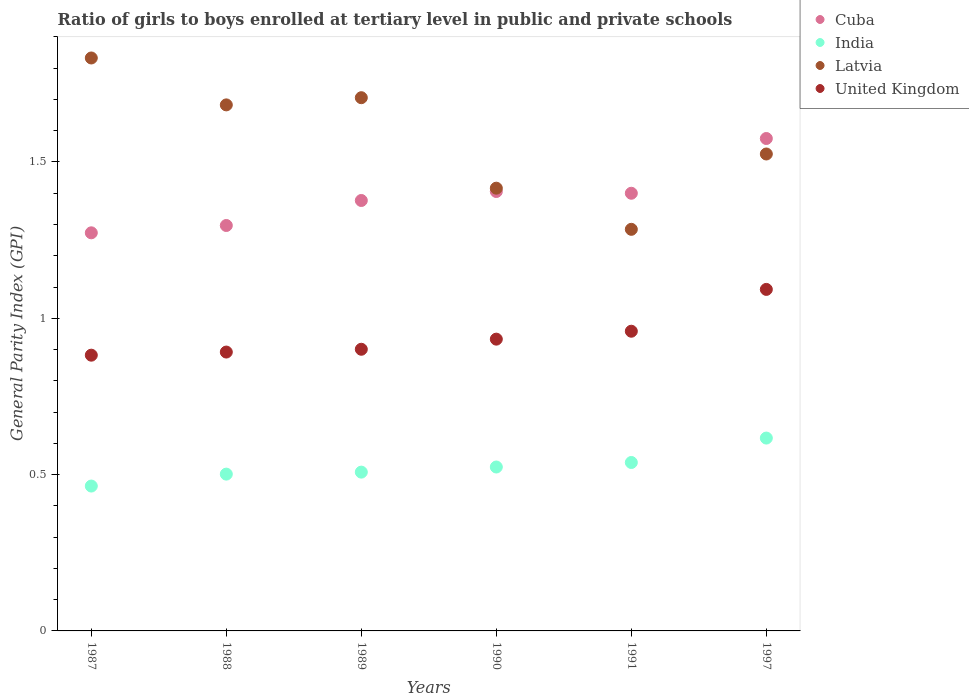How many different coloured dotlines are there?
Provide a short and direct response. 4. Is the number of dotlines equal to the number of legend labels?
Provide a short and direct response. Yes. What is the general parity index in India in 1988?
Give a very brief answer. 0.5. Across all years, what is the maximum general parity index in Cuba?
Offer a very short reply. 1.57. Across all years, what is the minimum general parity index in United Kingdom?
Offer a terse response. 0.88. In which year was the general parity index in Latvia maximum?
Offer a very short reply. 1987. What is the total general parity index in Latvia in the graph?
Ensure brevity in your answer.  9.45. What is the difference between the general parity index in United Kingdom in 1987 and that in 1989?
Make the answer very short. -0.02. What is the difference between the general parity index in United Kingdom in 1989 and the general parity index in India in 1990?
Your response must be concise. 0.38. What is the average general parity index in Latvia per year?
Provide a short and direct response. 1.57. In the year 1987, what is the difference between the general parity index in United Kingdom and general parity index in Latvia?
Give a very brief answer. -0.95. What is the ratio of the general parity index in Cuba in 1989 to that in 1991?
Make the answer very short. 0.98. Is the general parity index in Cuba in 1988 less than that in 1989?
Offer a terse response. Yes. Is the difference between the general parity index in United Kingdom in 1987 and 1997 greater than the difference between the general parity index in Latvia in 1987 and 1997?
Your answer should be compact. No. What is the difference between the highest and the second highest general parity index in United Kingdom?
Make the answer very short. 0.13. What is the difference between the highest and the lowest general parity index in Latvia?
Make the answer very short. 0.55. Is the sum of the general parity index in Cuba in 1988 and 1997 greater than the maximum general parity index in United Kingdom across all years?
Offer a terse response. Yes. Is it the case that in every year, the sum of the general parity index in Latvia and general parity index in India  is greater than the general parity index in United Kingdom?
Ensure brevity in your answer.  Yes. Does the general parity index in India monotonically increase over the years?
Ensure brevity in your answer.  Yes. How many years are there in the graph?
Ensure brevity in your answer.  6. What is the difference between two consecutive major ticks on the Y-axis?
Make the answer very short. 0.5. Are the values on the major ticks of Y-axis written in scientific E-notation?
Your answer should be compact. No. Does the graph contain any zero values?
Offer a very short reply. No. Where does the legend appear in the graph?
Provide a succinct answer. Top right. How many legend labels are there?
Your answer should be very brief. 4. How are the legend labels stacked?
Ensure brevity in your answer.  Vertical. What is the title of the graph?
Your response must be concise. Ratio of girls to boys enrolled at tertiary level in public and private schools. Does "Iran" appear as one of the legend labels in the graph?
Give a very brief answer. No. What is the label or title of the X-axis?
Offer a very short reply. Years. What is the label or title of the Y-axis?
Provide a short and direct response. General Parity Index (GPI). What is the General Parity Index (GPI) of Cuba in 1987?
Provide a short and direct response. 1.27. What is the General Parity Index (GPI) in India in 1987?
Offer a terse response. 0.46. What is the General Parity Index (GPI) in Latvia in 1987?
Your answer should be very brief. 1.83. What is the General Parity Index (GPI) of United Kingdom in 1987?
Ensure brevity in your answer.  0.88. What is the General Parity Index (GPI) in Cuba in 1988?
Ensure brevity in your answer.  1.3. What is the General Parity Index (GPI) of India in 1988?
Offer a very short reply. 0.5. What is the General Parity Index (GPI) of Latvia in 1988?
Your answer should be very brief. 1.68. What is the General Parity Index (GPI) in United Kingdom in 1988?
Your answer should be very brief. 0.89. What is the General Parity Index (GPI) in Cuba in 1989?
Give a very brief answer. 1.38. What is the General Parity Index (GPI) of India in 1989?
Keep it short and to the point. 0.51. What is the General Parity Index (GPI) in Latvia in 1989?
Offer a terse response. 1.71. What is the General Parity Index (GPI) of United Kingdom in 1989?
Keep it short and to the point. 0.9. What is the General Parity Index (GPI) of Cuba in 1990?
Keep it short and to the point. 1.41. What is the General Parity Index (GPI) in India in 1990?
Your response must be concise. 0.52. What is the General Parity Index (GPI) of Latvia in 1990?
Offer a very short reply. 1.42. What is the General Parity Index (GPI) of United Kingdom in 1990?
Provide a short and direct response. 0.93. What is the General Parity Index (GPI) of Cuba in 1991?
Ensure brevity in your answer.  1.4. What is the General Parity Index (GPI) of India in 1991?
Give a very brief answer. 0.54. What is the General Parity Index (GPI) in Latvia in 1991?
Your answer should be compact. 1.28. What is the General Parity Index (GPI) of United Kingdom in 1991?
Provide a succinct answer. 0.96. What is the General Parity Index (GPI) in Cuba in 1997?
Keep it short and to the point. 1.57. What is the General Parity Index (GPI) of India in 1997?
Provide a short and direct response. 0.62. What is the General Parity Index (GPI) of Latvia in 1997?
Give a very brief answer. 1.53. What is the General Parity Index (GPI) in United Kingdom in 1997?
Offer a very short reply. 1.09. Across all years, what is the maximum General Parity Index (GPI) in Cuba?
Your response must be concise. 1.57. Across all years, what is the maximum General Parity Index (GPI) of India?
Give a very brief answer. 0.62. Across all years, what is the maximum General Parity Index (GPI) in Latvia?
Offer a terse response. 1.83. Across all years, what is the maximum General Parity Index (GPI) of United Kingdom?
Make the answer very short. 1.09. Across all years, what is the minimum General Parity Index (GPI) in Cuba?
Ensure brevity in your answer.  1.27. Across all years, what is the minimum General Parity Index (GPI) of India?
Give a very brief answer. 0.46. Across all years, what is the minimum General Parity Index (GPI) of Latvia?
Provide a succinct answer. 1.28. Across all years, what is the minimum General Parity Index (GPI) of United Kingdom?
Provide a succinct answer. 0.88. What is the total General Parity Index (GPI) in Cuba in the graph?
Provide a short and direct response. 8.33. What is the total General Parity Index (GPI) in India in the graph?
Your response must be concise. 3.15. What is the total General Parity Index (GPI) of Latvia in the graph?
Offer a very short reply. 9.45. What is the total General Parity Index (GPI) of United Kingdom in the graph?
Ensure brevity in your answer.  5.66. What is the difference between the General Parity Index (GPI) of Cuba in 1987 and that in 1988?
Your answer should be compact. -0.02. What is the difference between the General Parity Index (GPI) in India in 1987 and that in 1988?
Keep it short and to the point. -0.04. What is the difference between the General Parity Index (GPI) in Latvia in 1987 and that in 1988?
Your response must be concise. 0.15. What is the difference between the General Parity Index (GPI) of United Kingdom in 1987 and that in 1988?
Provide a short and direct response. -0.01. What is the difference between the General Parity Index (GPI) in Cuba in 1987 and that in 1989?
Give a very brief answer. -0.1. What is the difference between the General Parity Index (GPI) of India in 1987 and that in 1989?
Your answer should be very brief. -0.04. What is the difference between the General Parity Index (GPI) of Latvia in 1987 and that in 1989?
Provide a short and direct response. 0.13. What is the difference between the General Parity Index (GPI) in United Kingdom in 1987 and that in 1989?
Provide a succinct answer. -0.02. What is the difference between the General Parity Index (GPI) in Cuba in 1987 and that in 1990?
Provide a short and direct response. -0.13. What is the difference between the General Parity Index (GPI) of India in 1987 and that in 1990?
Give a very brief answer. -0.06. What is the difference between the General Parity Index (GPI) of Latvia in 1987 and that in 1990?
Provide a short and direct response. 0.42. What is the difference between the General Parity Index (GPI) in United Kingdom in 1987 and that in 1990?
Make the answer very short. -0.05. What is the difference between the General Parity Index (GPI) of Cuba in 1987 and that in 1991?
Provide a short and direct response. -0.13. What is the difference between the General Parity Index (GPI) in India in 1987 and that in 1991?
Your answer should be very brief. -0.08. What is the difference between the General Parity Index (GPI) of Latvia in 1987 and that in 1991?
Provide a succinct answer. 0.55. What is the difference between the General Parity Index (GPI) in United Kingdom in 1987 and that in 1991?
Your answer should be compact. -0.08. What is the difference between the General Parity Index (GPI) of Cuba in 1987 and that in 1997?
Provide a succinct answer. -0.3. What is the difference between the General Parity Index (GPI) in India in 1987 and that in 1997?
Offer a terse response. -0.15. What is the difference between the General Parity Index (GPI) of Latvia in 1987 and that in 1997?
Offer a very short reply. 0.31. What is the difference between the General Parity Index (GPI) in United Kingdom in 1987 and that in 1997?
Keep it short and to the point. -0.21. What is the difference between the General Parity Index (GPI) of Cuba in 1988 and that in 1989?
Offer a terse response. -0.08. What is the difference between the General Parity Index (GPI) of India in 1988 and that in 1989?
Offer a very short reply. -0.01. What is the difference between the General Parity Index (GPI) in Latvia in 1988 and that in 1989?
Provide a short and direct response. -0.02. What is the difference between the General Parity Index (GPI) of United Kingdom in 1988 and that in 1989?
Give a very brief answer. -0.01. What is the difference between the General Parity Index (GPI) of Cuba in 1988 and that in 1990?
Provide a short and direct response. -0.11. What is the difference between the General Parity Index (GPI) of India in 1988 and that in 1990?
Your answer should be very brief. -0.02. What is the difference between the General Parity Index (GPI) of Latvia in 1988 and that in 1990?
Give a very brief answer. 0.27. What is the difference between the General Parity Index (GPI) in United Kingdom in 1988 and that in 1990?
Provide a short and direct response. -0.04. What is the difference between the General Parity Index (GPI) of Cuba in 1988 and that in 1991?
Your answer should be very brief. -0.1. What is the difference between the General Parity Index (GPI) of India in 1988 and that in 1991?
Offer a terse response. -0.04. What is the difference between the General Parity Index (GPI) of Latvia in 1988 and that in 1991?
Keep it short and to the point. 0.4. What is the difference between the General Parity Index (GPI) in United Kingdom in 1988 and that in 1991?
Offer a terse response. -0.07. What is the difference between the General Parity Index (GPI) in Cuba in 1988 and that in 1997?
Keep it short and to the point. -0.28. What is the difference between the General Parity Index (GPI) of India in 1988 and that in 1997?
Offer a terse response. -0.12. What is the difference between the General Parity Index (GPI) in Latvia in 1988 and that in 1997?
Ensure brevity in your answer.  0.16. What is the difference between the General Parity Index (GPI) of United Kingdom in 1988 and that in 1997?
Make the answer very short. -0.2. What is the difference between the General Parity Index (GPI) in Cuba in 1989 and that in 1990?
Your answer should be compact. -0.03. What is the difference between the General Parity Index (GPI) of India in 1989 and that in 1990?
Give a very brief answer. -0.02. What is the difference between the General Parity Index (GPI) in Latvia in 1989 and that in 1990?
Offer a terse response. 0.29. What is the difference between the General Parity Index (GPI) of United Kingdom in 1989 and that in 1990?
Ensure brevity in your answer.  -0.03. What is the difference between the General Parity Index (GPI) in Cuba in 1989 and that in 1991?
Keep it short and to the point. -0.02. What is the difference between the General Parity Index (GPI) of India in 1989 and that in 1991?
Provide a short and direct response. -0.03. What is the difference between the General Parity Index (GPI) of Latvia in 1989 and that in 1991?
Give a very brief answer. 0.42. What is the difference between the General Parity Index (GPI) of United Kingdom in 1989 and that in 1991?
Your answer should be very brief. -0.06. What is the difference between the General Parity Index (GPI) in Cuba in 1989 and that in 1997?
Ensure brevity in your answer.  -0.2. What is the difference between the General Parity Index (GPI) in India in 1989 and that in 1997?
Offer a terse response. -0.11. What is the difference between the General Parity Index (GPI) of Latvia in 1989 and that in 1997?
Offer a terse response. 0.18. What is the difference between the General Parity Index (GPI) in United Kingdom in 1989 and that in 1997?
Give a very brief answer. -0.19. What is the difference between the General Parity Index (GPI) of Cuba in 1990 and that in 1991?
Your answer should be very brief. 0.01. What is the difference between the General Parity Index (GPI) in India in 1990 and that in 1991?
Your answer should be compact. -0.01. What is the difference between the General Parity Index (GPI) in Latvia in 1990 and that in 1991?
Your answer should be compact. 0.13. What is the difference between the General Parity Index (GPI) in United Kingdom in 1990 and that in 1991?
Ensure brevity in your answer.  -0.03. What is the difference between the General Parity Index (GPI) in Cuba in 1990 and that in 1997?
Your response must be concise. -0.17. What is the difference between the General Parity Index (GPI) of India in 1990 and that in 1997?
Offer a very short reply. -0.09. What is the difference between the General Parity Index (GPI) in Latvia in 1990 and that in 1997?
Your response must be concise. -0.11. What is the difference between the General Parity Index (GPI) in United Kingdom in 1990 and that in 1997?
Ensure brevity in your answer.  -0.16. What is the difference between the General Parity Index (GPI) in Cuba in 1991 and that in 1997?
Provide a succinct answer. -0.18. What is the difference between the General Parity Index (GPI) in India in 1991 and that in 1997?
Provide a short and direct response. -0.08. What is the difference between the General Parity Index (GPI) of Latvia in 1991 and that in 1997?
Your response must be concise. -0.24. What is the difference between the General Parity Index (GPI) of United Kingdom in 1991 and that in 1997?
Offer a very short reply. -0.13. What is the difference between the General Parity Index (GPI) of Cuba in 1987 and the General Parity Index (GPI) of India in 1988?
Offer a terse response. 0.77. What is the difference between the General Parity Index (GPI) of Cuba in 1987 and the General Parity Index (GPI) of Latvia in 1988?
Offer a very short reply. -0.41. What is the difference between the General Parity Index (GPI) in Cuba in 1987 and the General Parity Index (GPI) in United Kingdom in 1988?
Offer a very short reply. 0.38. What is the difference between the General Parity Index (GPI) of India in 1987 and the General Parity Index (GPI) of Latvia in 1988?
Make the answer very short. -1.22. What is the difference between the General Parity Index (GPI) in India in 1987 and the General Parity Index (GPI) in United Kingdom in 1988?
Your answer should be compact. -0.43. What is the difference between the General Parity Index (GPI) in Latvia in 1987 and the General Parity Index (GPI) in United Kingdom in 1988?
Provide a succinct answer. 0.94. What is the difference between the General Parity Index (GPI) in Cuba in 1987 and the General Parity Index (GPI) in India in 1989?
Give a very brief answer. 0.77. What is the difference between the General Parity Index (GPI) of Cuba in 1987 and the General Parity Index (GPI) of Latvia in 1989?
Ensure brevity in your answer.  -0.43. What is the difference between the General Parity Index (GPI) of Cuba in 1987 and the General Parity Index (GPI) of United Kingdom in 1989?
Your answer should be compact. 0.37. What is the difference between the General Parity Index (GPI) in India in 1987 and the General Parity Index (GPI) in Latvia in 1989?
Keep it short and to the point. -1.24. What is the difference between the General Parity Index (GPI) in India in 1987 and the General Parity Index (GPI) in United Kingdom in 1989?
Provide a succinct answer. -0.44. What is the difference between the General Parity Index (GPI) in Latvia in 1987 and the General Parity Index (GPI) in United Kingdom in 1989?
Make the answer very short. 0.93. What is the difference between the General Parity Index (GPI) of Cuba in 1987 and the General Parity Index (GPI) of India in 1990?
Give a very brief answer. 0.75. What is the difference between the General Parity Index (GPI) of Cuba in 1987 and the General Parity Index (GPI) of Latvia in 1990?
Your answer should be very brief. -0.14. What is the difference between the General Parity Index (GPI) in Cuba in 1987 and the General Parity Index (GPI) in United Kingdom in 1990?
Ensure brevity in your answer.  0.34. What is the difference between the General Parity Index (GPI) of India in 1987 and the General Parity Index (GPI) of Latvia in 1990?
Keep it short and to the point. -0.95. What is the difference between the General Parity Index (GPI) of India in 1987 and the General Parity Index (GPI) of United Kingdom in 1990?
Offer a terse response. -0.47. What is the difference between the General Parity Index (GPI) in Latvia in 1987 and the General Parity Index (GPI) in United Kingdom in 1990?
Offer a very short reply. 0.9. What is the difference between the General Parity Index (GPI) in Cuba in 1987 and the General Parity Index (GPI) in India in 1991?
Keep it short and to the point. 0.73. What is the difference between the General Parity Index (GPI) of Cuba in 1987 and the General Parity Index (GPI) of Latvia in 1991?
Give a very brief answer. -0.01. What is the difference between the General Parity Index (GPI) of Cuba in 1987 and the General Parity Index (GPI) of United Kingdom in 1991?
Your answer should be very brief. 0.31. What is the difference between the General Parity Index (GPI) of India in 1987 and the General Parity Index (GPI) of Latvia in 1991?
Your answer should be compact. -0.82. What is the difference between the General Parity Index (GPI) of India in 1987 and the General Parity Index (GPI) of United Kingdom in 1991?
Provide a short and direct response. -0.5. What is the difference between the General Parity Index (GPI) in Latvia in 1987 and the General Parity Index (GPI) in United Kingdom in 1991?
Your answer should be very brief. 0.87. What is the difference between the General Parity Index (GPI) in Cuba in 1987 and the General Parity Index (GPI) in India in 1997?
Your answer should be very brief. 0.66. What is the difference between the General Parity Index (GPI) in Cuba in 1987 and the General Parity Index (GPI) in Latvia in 1997?
Offer a terse response. -0.25. What is the difference between the General Parity Index (GPI) of Cuba in 1987 and the General Parity Index (GPI) of United Kingdom in 1997?
Ensure brevity in your answer.  0.18. What is the difference between the General Parity Index (GPI) of India in 1987 and the General Parity Index (GPI) of Latvia in 1997?
Your answer should be very brief. -1.06. What is the difference between the General Parity Index (GPI) of India in 1987 and the General Parity Index (GPI) of United Kingdom in 1997?
Provide a succinct answer. -0.63. What is the difference between the General Parity Index (GPI) of Latvia in 1987 and the General Parity Index (GPI) of United Kingdom in 1997?
Give a very brief answer. 0.74. What is the difference between the General Parity Index (GPI) in Cuba in 1988 and the General Parity Index (GPI) in India in 1989?
Provide a short and direct response. 0.79. What is the difference between the General Parity Index (GPI) of Cuba in 1988 and the General Parity Index (GPI) of Latvia in 1989?
Your answer should be compact. -0.41. What is the difference between the General Parity Index (GPI) of Cuba in 1988 and the General Parity Index (GPI) of United Kingdom in 1989?
Give a very brief answer. 0.4. What is the difference between the General Parity Index (GPI) of India in 1988 and the General Parity Index (GPI) of Latvia in 1989?
Keep it short and to the point. -1.2. What is the difference between the General Parity Index (GPI) of India in 1988 and the General Parity Index (GPI) of United Kingdom in 1989?
Your answer should be compact. -0.4. What is the difference between the General Parity Index (GPI) in Latvia in 1988 and the General Parity Index (GPI) in United Kingdom in 1989?
Your response must be concise. 0.78. What is the difference between the General Parity Index (GPI) of Cuba in 1988 and the General Parity Index (GPI) of India in 1990?
Provide a short and direct response. 0.77. What is the difference between the General Parity Index (GPI) in Cuba in 1988 and the General Parity Index (GPI) in Latvia in 1990?
Provide a short and direct response. -0.12. What is the difference between the General Parity Index (GPI) of Cuba in 1988 and the General Parity Index (GPI) of United Kingdom in 1990?
Offer a terse response. 0.36. What is the difference between the General Parity Index (GPI) in India in 1988 and the General Parity Index (GPI) in Latvia in 1990?
Make the answer very short. -0.91. What is the difference between the General Parity Index (GPI) of India in 1988 and the General Parity Index (GPI) of United Kingdom in 1990?
Make the answer very short. -0.43. What is the difference between the General Parity Index (GPI) in Latvia in 1988 and the General Parity Index (GPI) in United Kingdom in 1990?
Your response must be concise. 0.75. What is the difference between the General Parity Index (GPI) in Cuba in 1988 and the General Parity Index (GPI) in India in 1991?
Your answer should be very brief. 0.76. What is the difference between the General Parity Index (GPI) of Cuba in 1988 and the General Parity Index (GPI) of Latvia in 1991?
Offer a very short reply. 0.01. What is the difference between the General Parity Index (GPI) in Cuba in 1988 and the General Parity Index (GPI) in United Kingdom in 1991?
Give a very brief answer. 0.34. What is the difference between the General Parity Index (GPI) of India in 1988 and the General Parity Index (GPI) of Latvia in 1991?
Give a very brief answer. -0.78. What is the difference between the General Parity Index (GPI) of India in 1988 and the General Parity Index (GPI) of United Kingdom in 1991?
Provide a short and direct response. -0.46. What is the difference between the General Parity Index (GPI) of Latvia in 1988 and the General Parity Index (GPI) of United Kingdom in 1991?
Make the answer very short. 0.72. What is the difference between the General Parity Index (GPI) in Cuba in 1988 and the General Parity Index (GPI) in India in 1997?
Provide a short and direct response. 0.68. What is the difference between the General Parity Index (GPI) of Cuba in 1988 and the General Parity Index (GPI) of Latvia in 1997?
Ensure brevity in your answer.  -0.23. What is the difference between the General Parity Index (GPI) in Cuba in 1988 and the General Parity Index (GPI) in United Kingdom in 1997?
Keep it short and to the point. 0.2. What is the difference between the General Parity Index (GPI) of India in 1988 and the General Parity Index (GPI) of Latvia in 1997?
Give a very brief answer. -1.02. What is the difference between the General Parity Index (GPI) in India in 1988 and the General Parity Index (GPI) in United Kingdom in 1997?
Your response must be concise. -0.59. What is the difference between the General Parity Index (GPI) in Latvia in 1988 and the General Parity Index (GPI) in United Kingdom in 1997?
Offer a terse response. 0.59. What is the difference between the General Parity Index (GPI) of Cuba in 1989 and the General Parity Index (GPI) of India in 1990?
Your answer should be compact. 0.85. What is the difference between the General Parity Index (GPI) in Cuba in 1989 and the General Parity Index (GPI) in Latvia in 1990?
Your response must be concise. -0.04. What is the difference between the General Parity Index (GPI) in Cuba in 1989 and the General Parity Index (GPI) in United Kingdom in 1990?
Your answer should be very brief. 0.44. What is the difference between the General Parity Index (GPI) of India in 1989 and the General Parity Index (GPI) of Latvia in 1990?
Your answer should be very brief. -0.91. What is the difference between the General Parity Index (GPI) in India in 1989 and the General Parity Index (GPI) in United Kingdom in 1990?
Give a very brief answer. -0.43. What is the difference between the General Parity Index (GPI) of Latvia in 1989 and the General Parity Index (GPI) of United Kingdom in 1990?
Keep it short and to the point. 0.77. What is the difference between the General Parity Index (GPI) in Cuba in 1989 and the General Parity Index (GPI) in India in 1991?
Give a very brief answer. 0.84. What is the difference between the General Parity Index (GPI) in Cuba in 1989 and the General Parity Index (GPI) in Latvia in 1991?
Provide a succinct answer. 0.09. What is the difference between the General Parity Index (GPI) of Cuba in 1989 and the General Parity Index (GPI) of United Kingdom in 1991?
Make the answer very short. 0.42. What is the difference between the General Parity Index (GPI) in India in 1989 and the General Parity Index (GPI) in Latvia in 1991?
Your answer should be compact. -0.78. What is the difference between the General Parity Index (GPI) of India in 1989 and the General Parity Index (GPI) of United Kingdom in 1991?
Your answer should be compact. -0.45. What is the difference between the General Parity Index (GPI) in Latvia in 1989 and the General Parity Index (GPI) in United Kingdom in 1991?
Keep it short and to the point. 0.75. What is the difference between the General Parity Index (GPI) of Cuba in 1989 and the General Parity Index (GPI) of India in 1997?
Your answer should be very brief. 0.76. What is the difference between the General Parity Index (GPI) in Cuba in 1989 and the General Parity Index (GPI) in Latvia in 1997?
Make the answer very short. -0.15. What is the difference between the General Parity Index (GPI) in Cuba in 1989 and the General Parity Index (GPI) in United Kingdom in 1997?
Your answer should be compact. 0.28. What is the difference between the General Parity Index (GPI) of India in 1989 and the General Parity Index (GPI) of Latvia in 1997?
Give a very brief answer. -1.02. What is the difference between the General Parity Index (GPI) of India in 1989 and the General Parity Index (GPI) of United Kingdom in 1997?
Keep it short and to the point. -0.58. What is the difference between the General Parity Index (GPI) in Latvia in 1989 and the General Parity Index (GPI) in United Kingdom in 1997?
Provide a succinct answer. 0.61. What is the difference between the General Parity Index (GPI) in Cuba in 1990 and the General Parity Index (GPI) in India in 1991?
Offer a very short reply. 0.87. What is the difference between the General Parity Index (GPI) of Cuba in 1990 and the General Parity Index (GPI) of Latvia in 1991?
Give a very brief answer. 0.12. What is the difference between the General Parity Index (GPI) of Cuba in 1990 and the General Parity Index (GPI) of United Kingdom in 1991?
Make the answer very short. 0.45. What is the difference between the General Parity Index (GPI) of India in 1990 and the General Parity Index (GPI) of Latvia in 1991?
Provide a succinct answer. -0.76. What is the difference between the General Parity Index (GPI) in India in 1990 and the General Parity Index (GPI) in United Kingdom in 1991?
Provide a succinct answer. -0.43. What is the difference between the General Parity Index (GPI) of Latvia in 1990 and the General Parity Index (GPI) of United Kingdom in 1991?
Give a very brief answer. 0.46. What is the difference between the General Parity Index (GPI) in Cuba in 1990 and the General Parity Index (GPI) in India in 1997?
Your answer should be very brief. 0.79. What is the difference between the General Parity Index (GPI) in Cuba in 1990 and the General Parity Index (GPI) in Latvia in 1997?
Keep it short and to the point. -0.12. What is the difference between the General Parity Index (GPI) in Cuba in 1990 and the General Parity Index (GPI) in United Kingdom in 1997?
Give a very brief answer. 0.31. What is the difference between the General Parity Index (GPI) of India in 1990 and the General Parity Index (GPI) of Latvia in 1997?
Keep it short and to the point. -1. What is the difference between the General Parity Index (GPI) in India in 1990 and the General Parity Index (GPI) in United Kingdom in 1997?
Provide a short and direct response. -0.57. What is the difference between the General Parity Index (GPI) in Latvia in 1990 and the General Parity Index (GPI) in United Kingdom in 1997?
Your response must be concise. 0.32. What is the difference between the General Parity Index (GPI) of Cuba in 1991 and the General Parity Index (GPI) of India in 1997?
Your answer should be very brief. 0.78. What is the difference between the General Parity Index (GPI) in Cuba in 1991 and the General Parity Index (GPI) in Latvia in 1997?
Your answer should be compact. -0.13. What is the difference between the General Parity Index (GPI) in Cuba in 1991 and the General Parity Index (GPI) in United Kingdom in 1997?
Offer a very short reply. 0.31. What is the difference between the General Parity Index (GPI) of India in 1991 and the General Parity Index (GPI) of Latvia in 1997?
Make the answer very short. -0.99. What is the difference between the General Parity Index (GPI) of India in 1991 and the General Parity Index (GPI) of United Kingdom in 1997?
Your answer should be very brief. -0.55. What is the difference between the General Parity Index (GPI) in Latvia in 1991 and the General Parity Index (GPI) in United Kingdom in 1997?
Ensure brevity in your answer.  0.19. What is the average General Parity Index (GPI) in Cuba per year?
Your answer should be compact. 1.39. What is the average General Parity Index (GPI) of India per year?
Offer a very short reply. 0.53. What is the average General Parity Index (GPI) of Latvia per year?
Provide a short and direct response. 1.57. What is the average General Parity Index (GPI) in United Kingdom per year?
Keep it short and to the point. 0.94. In the year 1987, what is the difference between the General Parity Index (GPI) of Cuba and General Parity Index (GPI) of India?
Offer a very short reply. 0.81. In the year 1987, what is the difference between the General Parity Index (GPI) in Cuba and General Parity Index (GPI) in Latvia?
Offer a terse response. -0.56. In the year 1987, what is the difference between the General Parity Index (GPI) of Cuba and General Parity Index (GPI) of United Kingdom?
Offer a very short reply. 0.39. In the year 1987, what is the difference between the General Parity Index (GPI) in India and General Parity Index (GPI) in Latvia?
Your answer should be compact. -1.37. In the year 1987, what is the difference between the General Parity Index (GPI) of India and General Parity Index (GPI) of United Kingdom?
Make the answer very short. -0.42. In the year 1987, what is the difference between the General Parity Index (GPI) of Latvia and General Parity Index (GPI) of United Kingdom?
Give a very brief answer. 0.95. In the year 1988, what is the difference between the General Parity Index (GPI) in Cuba and General Parity Index (GPI) in India?
Offer a terse response. 0.8. In the year 1988, what is the difference between the General Parity Index (GPI) of Cuba and General Parity Index (GPI) of Latvia?
Provide a succinct answer. -0.39. In the year 1988, what is the difference between the General Parity Index (GPI) in Cuba and General Parity Index (GPI) in United Kingdom?
Ensure brevity in your answer.  0.4. In the year 1988, what is the difference between the General Parity Index (GPI) in India and General Parity Index (GPI) in Latvia?
Make the answer very short. -1.18. In the year 1988, what is the difference between the General Parity Index (GPI) in India and General Parity Index (GPI) in United Kingdom?
Ensure brevity in your answer.  -0.39. In the year 1988, what is the difference between the General Parity Index (GPI) of Latvia and General Parity Index (GPI) of United Kingdom?
Ensure brevity in your answer.  0.79. In the year 1989, what is the difference between the General Parity Index (GPI) in Cuba and General Parity Index (GPI) in India?
Make the answer very short. 0.87. In the year 1989, what is the difference between the General Parity Index (GPI) of Cuba and General Parity Index (GPI) of Latvia?
Provide a succinct answer. -0.33. In the year 1989, what is the difference between the General Parity Index (GPI) in Cuba and General Parity Index (GPI) in United Kingdom?
Offer a terse response. 0.48. In the year 1989, what is the difference between the General Parity Index (GPI) of India and General Parity Index (GPI) of Latvia?
Provide a succinct answer. -1.2. In the year 1989, what is the difference between the General Parity Index (GPI) in India and General Parity Index (GPI) in United Kingdom?
Provide a succinct answer. -0.39. In the year 1989, what is the difference between the General Parity Index (GPI) in Latvia and General Parity Index (GPI) in United Kingdom?
Offer a terse response. 0.8. In the year 1990, what is the difference between the General Parity Index (GPI) of Cuba and General Parity Index (GPI) of India?
Make the answer very short. 0.88. In the year 1990, what is the difference between the General Parity Index (GPI) of Cuba and General Parity Index (GPI) of Latvia?
Make the answer very short. -0.01. In the year 1990, what is the difference between the General Parity Index (GPI) in Cuba and General Parity Index (GPI) in United Kingdom?
Offer a terse response. 0.47. In the year 1990, what is the difference between the General Parity Index (GPI) of India and General Parity Index (GPI) of Latvia?
Give a very brief answer. -0.89. In the year 1990, what is the difference between the General Parity Index (GPI) in India and General Parity Index (GPI) in United Kingdom?
Your answer should be compact. -0.41. In the year 1990, what is the difference between the General Parity Index (GPI) of Latvia and General Parity Index (GPI) of United Kingdom?
Your answer should be very brief. 0.48. In the year 1991, what is the difference between the General Parity Index (GPI) in Cuba and General Parity Index (GPI) in India?
Offer a very short reply. 0.86. In the year 1991, what is the difference between the General Parity Index (GPI) in Cuba and General Parity Index (GPI) in Latvia?
Offer a terse response. 0.12. In the year 1991, what is the difference between the General Parity Index (GPI) in Cuba and General Parity Index (GPI) in United Kingdom?
Ensure brevity in your answer.  0.44. In the year 1991, what is the difference between the General Parity Index (GPI) in India and General Parity Index (GPI) in Latvia?
Provide a succinct answer. -0.75. In the year 1991, what is the difference between the General Parity Index (GPI) of India and General Parity Index (GPI) of United Kingdom?
Provide a succinct answer. -0.42. In the year 1991, what is the difference between the General Parity Index (GPI) of Latvia and General Parity Index (GPI) of United Kingdom?
Give a very brief answer. 0.33. In the year 1997, what is the difference between the General Parity Index (GPI) in Cuba and General Parity Index (GPI) in India?
Offer a terse response. 0.96. In the year 1997, what is the difference between the General Parity Index (GPI) in Cuba and General Parity Index (GPI) in Latvia?
Make the answer very short. 0.05. In the year 1997, what is the difference between the General Parity Index (GPI) of Cuba and General Parity Index (GPI) of United Kingdom?
Your answer should be compact. 0.48. In the year 1997, what is the difference between the General Parity Index (GPI) in India and General Parity Index (GPI) in Latvia?
Keep it short and to the point. -0.91. In the year 1997, what is the difference between the General Parity Index (GPI) in India and General Parity Index (GPI) in United Kingdom?
Make the answer very short. -0.48. In the year 1997, what is the difference between the General Parity Index (GPI) in Latvia and General Parity Index (GPI) in United Kingdom?
Keep it short and to the point. 0.43. What is the ratio of the General Parity Index (GPI) of India in 1987 to that in 1988?
Your response must be concise. 0.92. What is the ratio of the General Parity Index (GPI) in Latvia in 1987 to that in 1988?
Keep it short and to the point. 1.09. What is the ratio of the General Parity Index (GPI) in Cuba in 1987 to that in 1989?
Provide a short and direct response. 0.92. What is the ratio of the General Parity Index (GPI) of India in 1987 to that in 1989?
Make the answer very short. 0.91. What is the ratio of the General Parity Index (GPI) in Latvia in 1987 to that in 1989?
Provide a short and direct response. 1.07. What is the ratio of the General Parity Index (GPI) in Cuba in 1987 to that in 1990?
Provide a succinct answer. 0.91. What is the ratio of the General Parity Index (GPI) in India in 1987 to that in 1990?
Give a very brief answer. 0.88. What is the ratio of the General Parity Index (GPI) in Latvia in 1987 to that in 1990?
Offer a terse response. 1.29. What is the ratio of the General Parity Index (GPI) of United Kingdom in 1987 to that in 1990?
Offer a very short reply. 0.95. What is the ratio of the General Parity Index (GPI) of Cuba in 1987 to that in 1991?
Make the answer very short. 0.91. What is the ratio of the General Parity Index (GPI) in India in 1987 to that in 1991?
Ensure brevity in your answer.  0.86. What is the ratio of the General Parity Index (GPI) of Latvia in 1987 to that in 1991?
Your answer should be very brief. 1.43. What is the ratio of the General Parity Index (GPI) of United Kingdom in 1987 to that in 1991?
Provide a succinct answer. 0.92. What is the ratio of the General Parity Index (GPI) of Cuba in 1987 to that in 1997?
Ensure brevity in your answer.  0.81. What is the ratio of the General Parity Index (GPI) of India in 1987 to that in 1997?
Offer a terse response. 0.75. What is the ratio of the General Parity Index (GPI) of Latvia in 1987 to that in 1997?
Provide a short and direct response. 1.2. What is the ratio of the General Parity Index (GPI) of United Kingdom in 1987 to that in 1997?
Give a very brief answer. 0.81. What is the ratio of the General Parity Index (GPI) of Cuba in 1988 to that in 1989?
Your answer should be very brief. 0.94. What is the ratio of the General Parity Index (GPI) in India in 1988 to that in 1989?
Offer a terse response. 0.99. What is the ratio of the General Parity Index (GPI) in Latvia in 1988 to that in 1989?
Ensure brevity in your answer.  0.99. What is the ratio of the General Parity Index (GPI) of United Kingdom in 1988 to that in 1989?
Your answer should be compact. 0.99. What is the ratio of the General Parity Index (GPI) in Cuba in 1988 to that in 1990?
Offer a terse response. 0.92. What is the ratio of the General Parity Index (GPI) of India in 1988 to that in 1990?
Your answer should be compact. 0.96. What is the ratio of the General Parity Index (GPI) in Latvia in 1988 to that in 1990?
Ensure brevity in your answer.  1.19. What is the ratio of the General Parity Index (GPI) of United Kingdom in 1988 to that in 1990?
Provide a succinct answer. 0.96. What is the ratio of the General Parity Index (GPI) of Cuba in 1988 to that in 1991?
Your answer should be very brief. 0.93. What is the ratio of the General Parity Index (GPI) in India in 1988 to that in 1991?
Offer a very short reply. 0.93. What is the ratio of the General Parity Index (GPI) in Latvia in 1988 to that in 1991?
Your response must be concise. 1.31. What is the ratio of the General Parity Index (GPI) of United Kingdom in 1988 to that in 1991?
Offer a very short reply. 0.93. What is the ratio of the General Parity Index (GPI) in Cuba in 1988 to that in 1997?
Ensure brevity in your answer.  0.82. What is the ratio of the General Parity Index (GPI) in India in 1988 to that in 1997?
Offer a terse response. 0.81. What is the ratio of the General Parity Index (GPI) of Latvia in 1988 to that in 1997?
Ensure brevity in your answer.  1.1. What is the ratio of the General Parity Index (GPI) of United Kingdom in 1988 to that in 1997?
Keep it short and to the point. 0.82. What is the ratio of the General Parity Index (GPI) of Cuba in 1989 to that in 1990?
Make the answer very short. 0.98. What is the ratio of the General Parity Index (GPI) in India in 1989 to that in 1990?
Offer a very short reply. 0.97. What is the ratio of the General Parity Index (GPI) of Latvia in 1989 to that in 1990?
Your response must be concise. 1.2. What is the ratio of the General Parity Index (GPI) of United Kingdom in 1989 to that in 1990?
Your response must be concise. 0.97. What is the ratio of the General Parity Index (GPI) in Cuba in 1989 to that in 1991?
Your answer should be compact. 0.98. What is the ratio of the General Parity Index (GPI) of India in 1989 to that in 1991?
Provide a short and direct response. 0.94. What is the ratio of the General Parity Index (GPI) in Latvia in 1989 to that in 1991?
Your response must be concise. 1.33. What is the ratio of the General Parity Index (GPI) in United Kingdom in 1989 to that in 1991?
Make the answer very short. 0.94. What is the ratio of the General Parity Index (GPI) of Cuba in 1989 to that in 1997?
Your answer should be very brief. 0.87. What is the ratio of the General Parity Index (GPI) of India in 1989 to that in 1997?
Your response must be concise. 0.82. What is the ratio of the General Parity Index (GPI) of Latvia in 1989 to that in 1997?
Keep it short and to the point. 1.12. What is the ratio of the General Parity Index (GPI) of United Kingdom in 1989 to that in 1997?
Your answer should be very brief. 0.82. What is the ratio of the General Parity Index (GPI) of Cuba in 1990 to that in 1991?
Give a very brief answer. 1. What is the ratio of the General Parity Index (GPI) in India in 1990 to that in 1991?
Your answer should be compact. 0.97. What is the ratio of the General Parity Index (GPI) in Latvia in 1990 to that in 1991?
Give a very brief answer. 1.1. What is the ratio of the General Parity Index (GPI) of United Kingdom in 1990 to that in 1991?
Make the answer very short. 0.97. What is the ratio of the General Parity Index (GPI) of Cuba in 1990 to that in 1997?
Provide a short and direct response. 0.89. What is the ratio of the General Parity Index (GPI) in India in 1990 to that in 1997?
Provide a succinct answer. 0.85. What is the ratio of the General Parity Index (GPI) of Latvia in 1990 to that in 1997?
Your answer should be very brief. 0.93. What is the ratio of the General Parity Index (GPI) of United Kingdom in 1990 to that in 1997?
Ensure brevity in your answer.  0.85. What is the ratio of the General Parity Index (GPI) of Cuba in 1991 to that in 1997?
Give a very brief answer. 0.89. What is the ratio of the General Parity Index (GPI) of India in 1991 to that in 1997?
Give a very brief answer. 0.87. What is the ratio of the General Parity Index (GPI) in Latvia in 1991 to that in 1997?
Keep it short and to the point. 0.84. What is the ratio of the General Parity Index (GPI) in United Kingdom in 1991 to that in 1997?
Ensure brevity in your answer.  0.88. What is the difference between the highest and the second highest General Parity Index (GPI) of Cuba?
Provide a succinct answer. 0.17. What is the difference between the highest and the second highest General Parity Index (GPI) of India?
Keep it short and to the point. 0.08. What is the difference between the highest and the second highest General Parity Index (GPI) in Latvia?
Offer a very short reply. 0.13. What is the difference between the highest and the second highest General Parity Index (GPI) in United Kingdom?
Offer a very short reply. 0.13. What is the difference between the highest and the lowest General Parity Index (GPI) in Cuba?
Offer a terse response. 0.3. What is the difference between the highest and the lowest General Parity Index (GPI) of India?
Offer a terse response. 0.15. What is the difference between the highest and the lowest General Parity Index (GPI) in Latvia?
Your response must be concise. 0.55. What is the difference between the highest and the lowest General Parity Index (GPI) of United Kingdom?
Give a very brief answer. 0.21. 